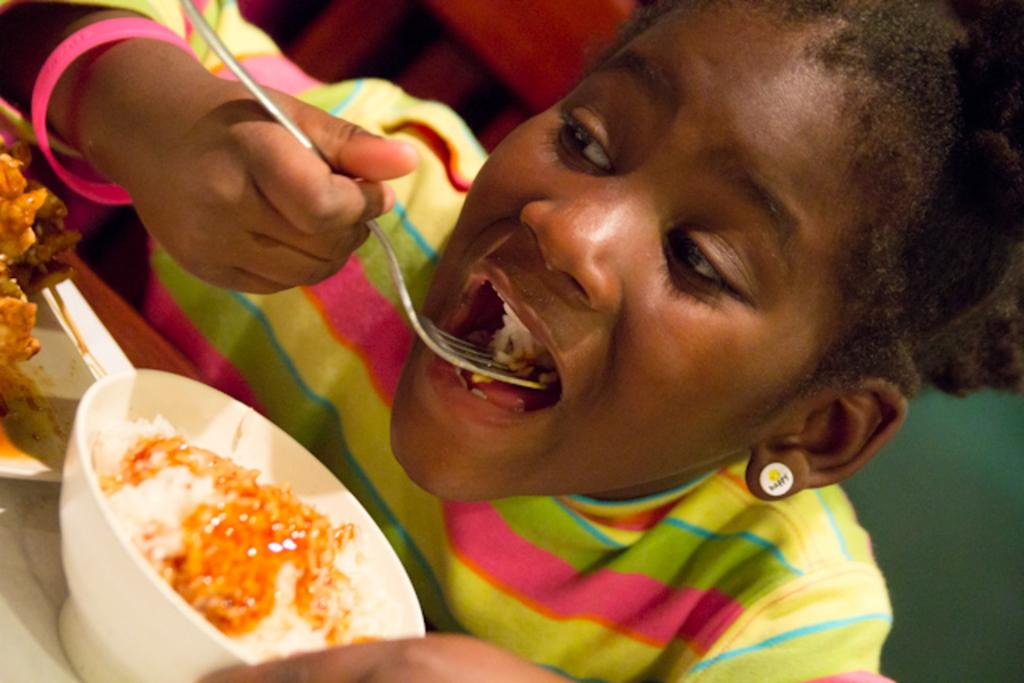What is the person in the image holding? The person is holding a fork. What is the person doing with the fork? The person is eating food. What can be seen on the table in the image? There is a bowl, a plate, and food on the table. How is the background of the image depicted? The background is blurred. What is the name of the person eating food in the image? The provided facts do not include the name of the person in the image. Is there a crook present in the image? There is no mention of a crook in the provided facts, and therefore no such object can be observed in the image. 